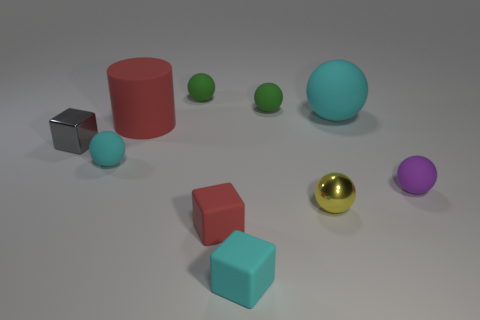Are there any spheres that have the same material as the small gray thing? Yes, there is one sphere with the same matte finish as the small gray cube, positioned to the far left in the image. 